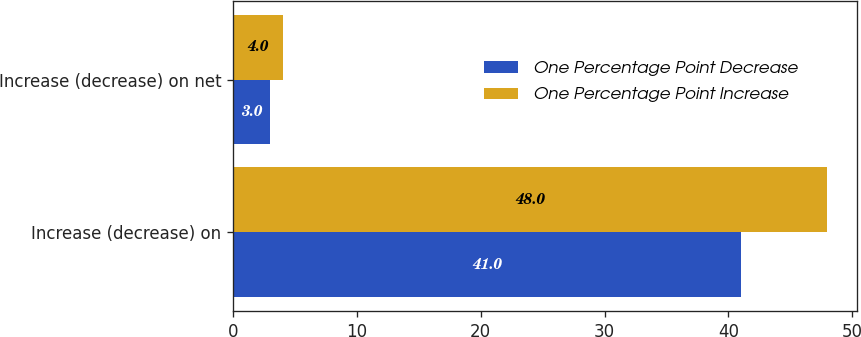<chart> <loc_0><loc_0><loc_500><loc_500><stacked_bar_chart><ecel><fcel>Increase (decrease) on<fcel>Increase (decrease) on net<nl><fcel>One Percentage Point Decrease<fcel>41<fcel>3<nl><fcel>One Percentage Point Increase<fcel>48<fcel>4<nl></chart> 